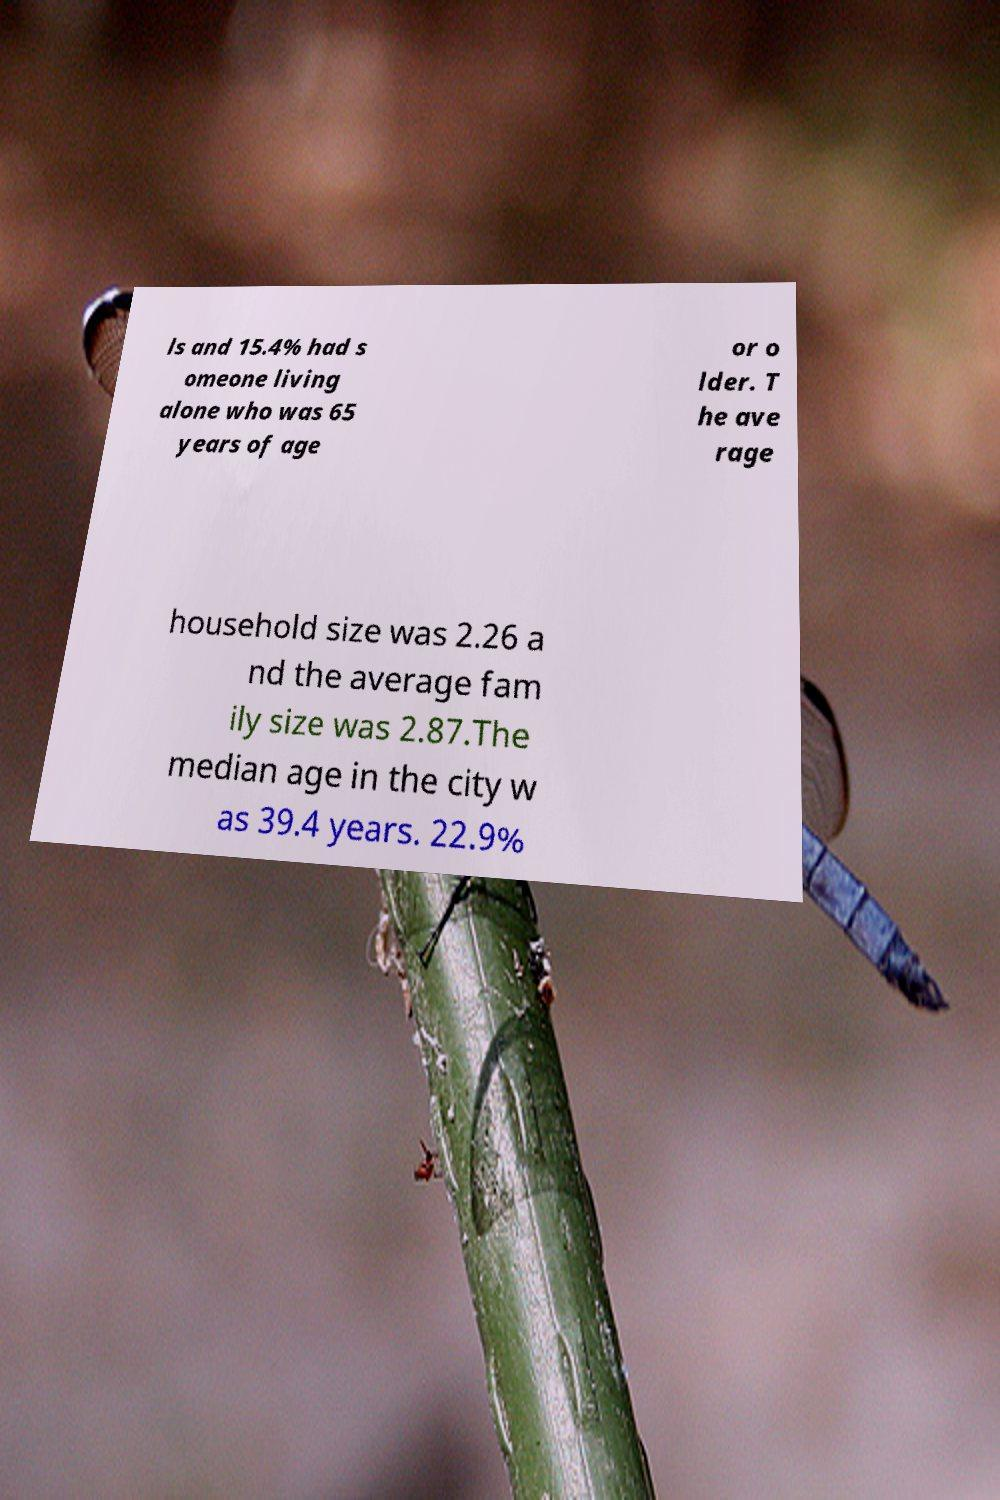Can you accurately transcribe the text from the provided image for me? ls and 15.4% had s omeone living alone who was 65 years of age or o lder. T he ave rage household size was 2.26 a nd the average fam ily size was 2.87.The median age in the city w as 39.4 years. 22.9% 